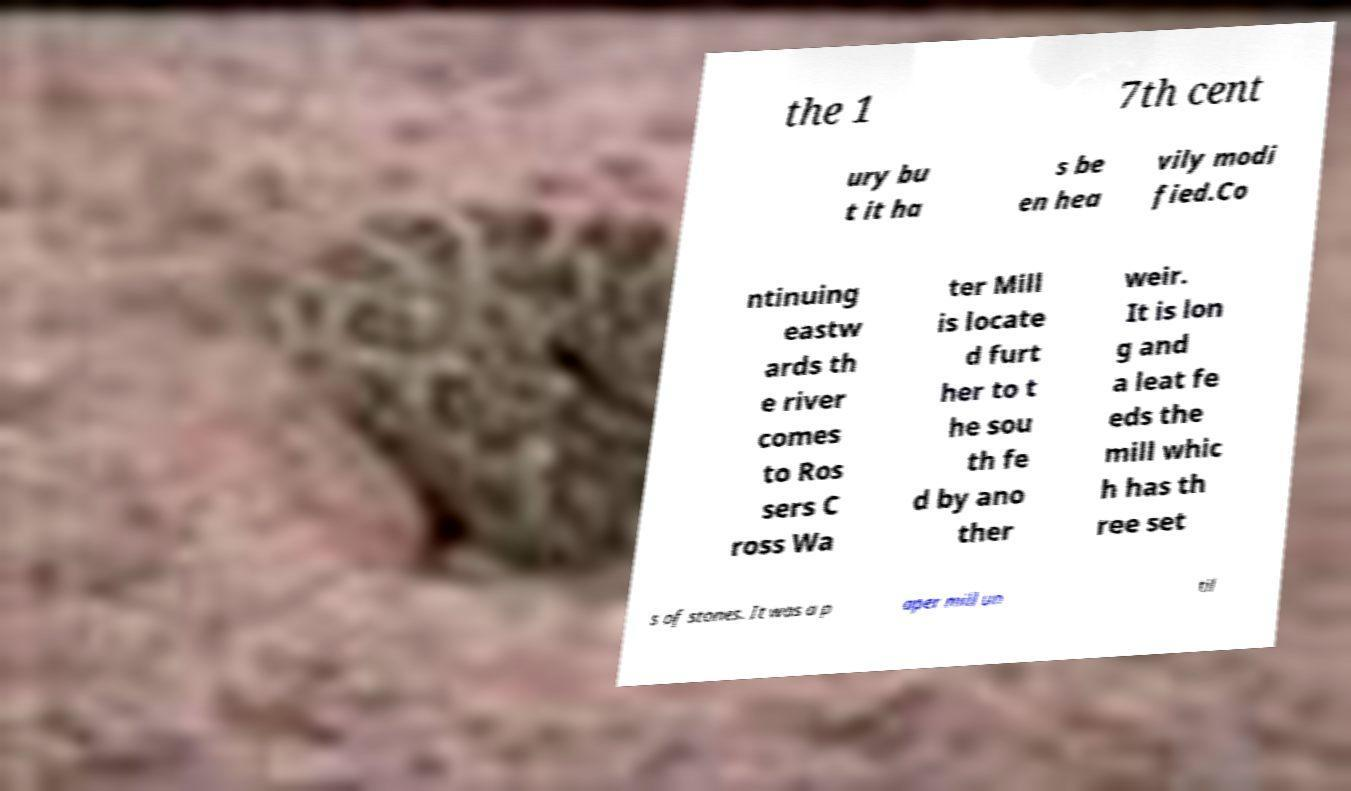I need the written content from this picture converted into text. Can you do that? the 1 7th cent ury bu t it ha s be en hea vily modi fied.Co ntinuing eastw ards th e river comes to Ros sers C ross Wa ter Mill is locate d furt her to t he sou th fe d by ano ther weir. It is lon g and a leat fe eds the mill whic h has th ree set s of stones. It was a p aper mill un til 